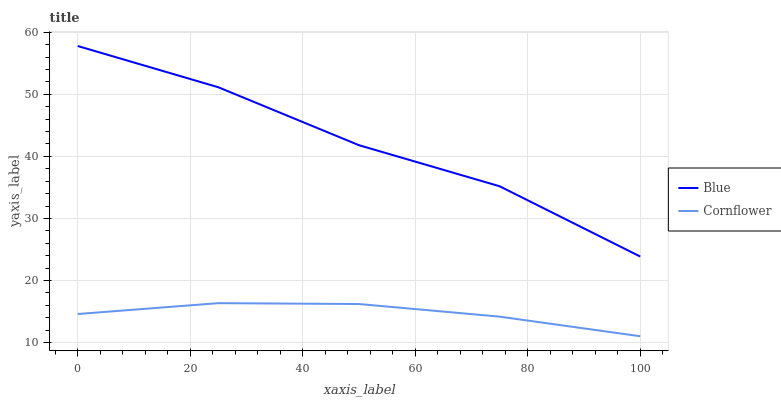Does Cornflower have the minimum area under the curve?
Answer yes or no. Yes. Does Blue have the maximum area under the curve?
Answer yes or no. Yes. Does Cornflower have the maximum area under the curve?
Answer yes or no. No. Is Cornflower the smoothest?
Answer yes or no. Yes. Is Blue the roughest?
Answer yes or no. Yes. Is Cornflower the roughest?
Answer yes or no. No. Does Cornflower have the lowest value?
Answer yes or no. Yes. Does Blue have the highest value?
Answer yes or no. Yes. Does Cornflower have the highest value?
Answer yes or no. No. Is Cornflower less than Blue?
Answer yes or no. Yes. Is Blue greater than Cornflower?
Answer yes or no. Yes. Does Cornflower intersect Blue?
Answer yes or no. No. 